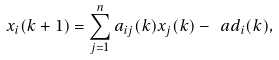Convert formula to latex. <formula><loc_0><loc_0><loc_500><loc_500>x _ { i } ( k + 1 ) = \sum _ { j = 1 } ^ { n } a _ { i j } ( k ) x _ { j } ( k ) - \ a d _ { i } ( k ) ,</formula> 